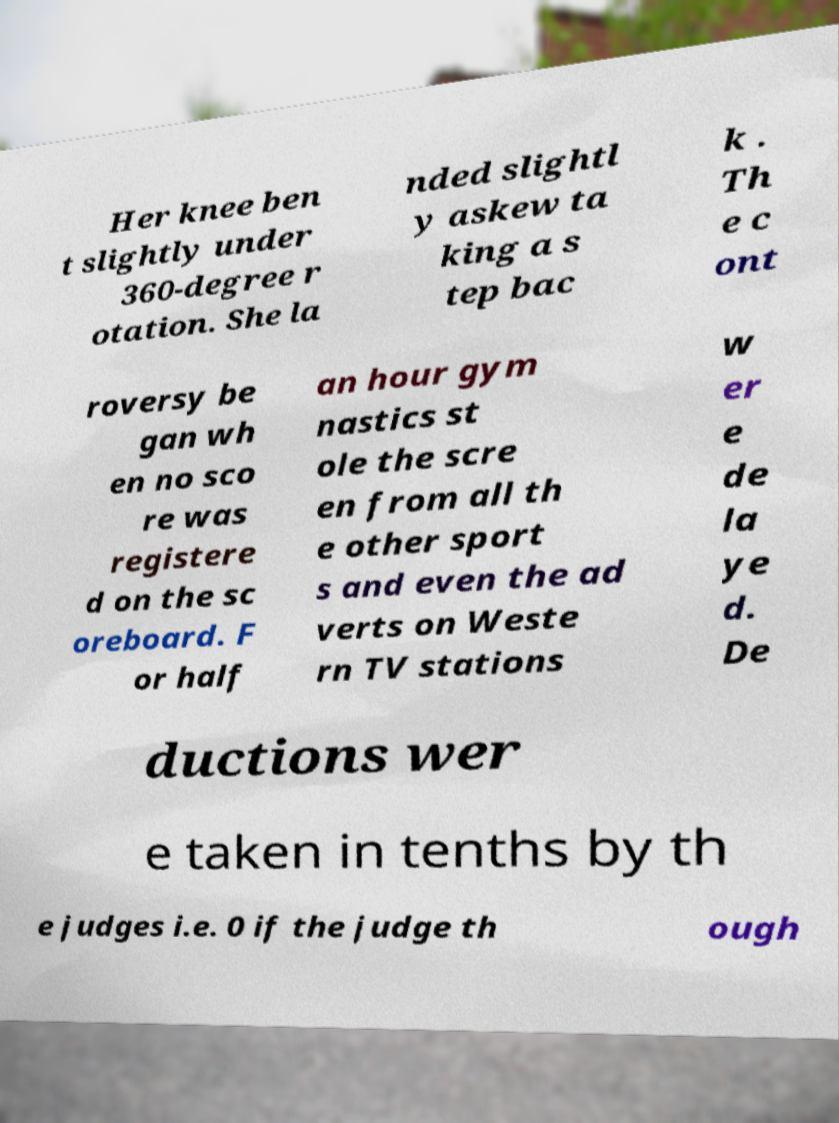I need the written content from this picture converted into text. Can you do that? Her knee ben t slightly under 360-degree r otation. She la nded slightl y askew ta king a s tep bac k . Th e c ont roversy be gan wh en no sco re was registere d on the sc oreboard. F or half an hour gym nastics st ole the scre en from all th e other sport s and even the ad verts on Weste rn TV stations w er e de la ye d. De ductions wer e taken in tenths by th e judges i.e. 0 if the judge th ough 